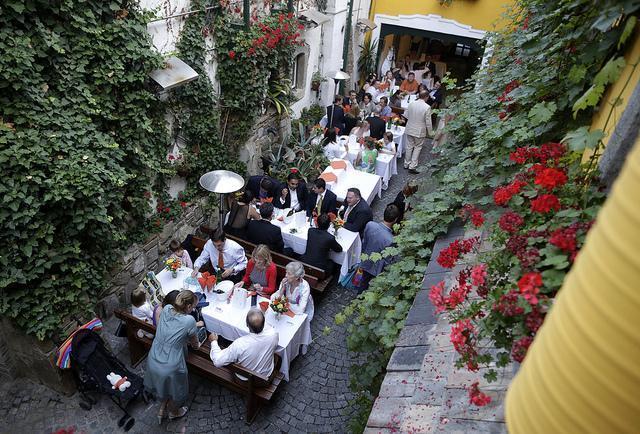How many people can be seen?
Give a very brief answer. 3. 